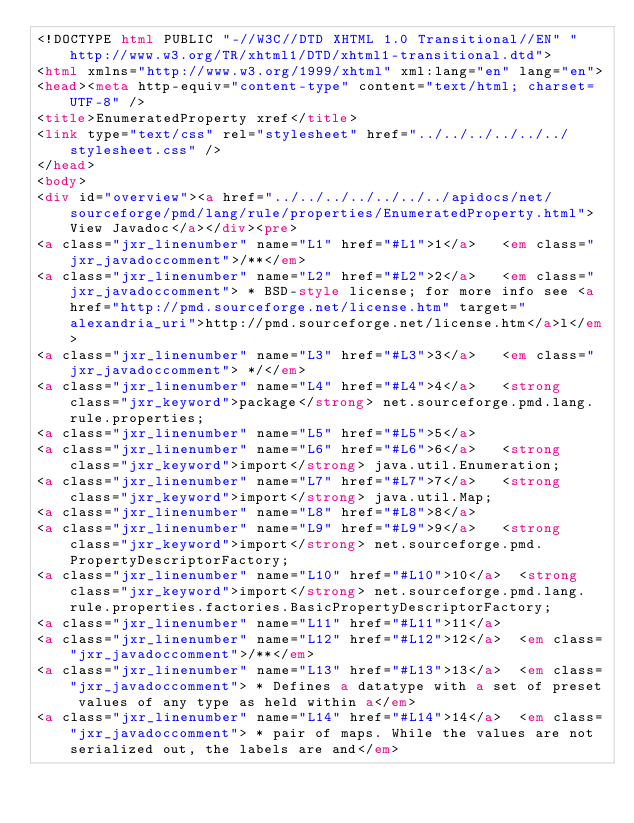Convert code to text. <code><loc_0><loc_0><loc_500><loc_500><_HTML_><!DOCTYPE html PUBLIC "-//W3C//DTD XHTML 1.0 Transitional//EN" "http://www.w3.org/TR/xhtml1/DTD/xhtml1-transitional.dtd">
<html xmlns="http://www.w3.org/1999/xhtml" xml:lang="en" lang="en">
<head><meta http-equiv="content-type" content="text/html; charset=UTF-8" />
<title>EnumeratedProperty xref</title>
<link type="text/css" rel="stylesheet" href="../../../../../../stylesheet.css" />
</head>
<body>
<div id="overview"><a href="../../../../../../../apidocs/net/sourceforge/pmd/lang/rule/properties/EnumeratedProperty.html">View Javadoc</a></div><pre>
<a class="jxr_linenumber" name="L1" href="#L1">1</a>   <em class="jxr_javadoccomment">/**</em>
<a class="jxr_linenumber" name="L2" href="#L2">2</a>   <em class="jxr_javadoccomment"> * BSD-style license; for more info see <a href="http://pmd.sourceforge.net/license.htm" target="alexandria_uri">http://pmd.sourceforge.net/license.htm</a>l</em>
<a class="jxr_linenumber" name="L3" href="#L3">3</a>   <em class="jxr_javadoccomment"> */</em>
<a class="jxr_linenumber" name="L4" href="#L4">4</a>   <strong class="jxr_keyword">package</strong> net.sourceforge.pmd.lang.rule.properties;
<a class="jxr_linenumber" name="L5" href="#L5">5</a>   
<a class="jxr_linenumber" name="L6" href="#L6">6</a>   <strong class="jxr_keyword">import</strong> java.util.Enumeration;
<a class="jxr_linenumber" name="L7" href="#L7">7</a>   <strong class="jxr_keyword">import</strong> java.util.Map;
<a class="jxr_linenumber" name="L8" href="#L8">8</a>   
<a class="jxr_linenumber" name="L9" href="#L9">9</a>   <strong class="jxr_keyword">import</strong> net.sourceforge.pmd.PropertyDescriptorFactory;
<a class="jxr_linenumber" name="L10" href="#L10">10</a>  <strong class="jxr_keyword">import</strong> net.sourceforge.pmd.lang.rule.properties.factories.BasicPropertyDescriptorFactory;
<a class="jxr_linenumber" name="L11" href="#L11">11</a>  
<a class="jxr_linenumber" name="L12" href="#L12">12</a>  <em class="jxr_javadoccomment">/**</em>
<a class="jxr_linenumber" name="L13" href="#L13">13</a>  <em class="jxr_javadoccomment"> * Defines a datatype with a set of preset values of any type as held within a</em>
<a class="jxr_linenumber" name="L14" href="#L14">14</a>  <em class="jxr_javadoccomment"> * pair of maps. While the values are not serialized out, the labels are and</em></code> 